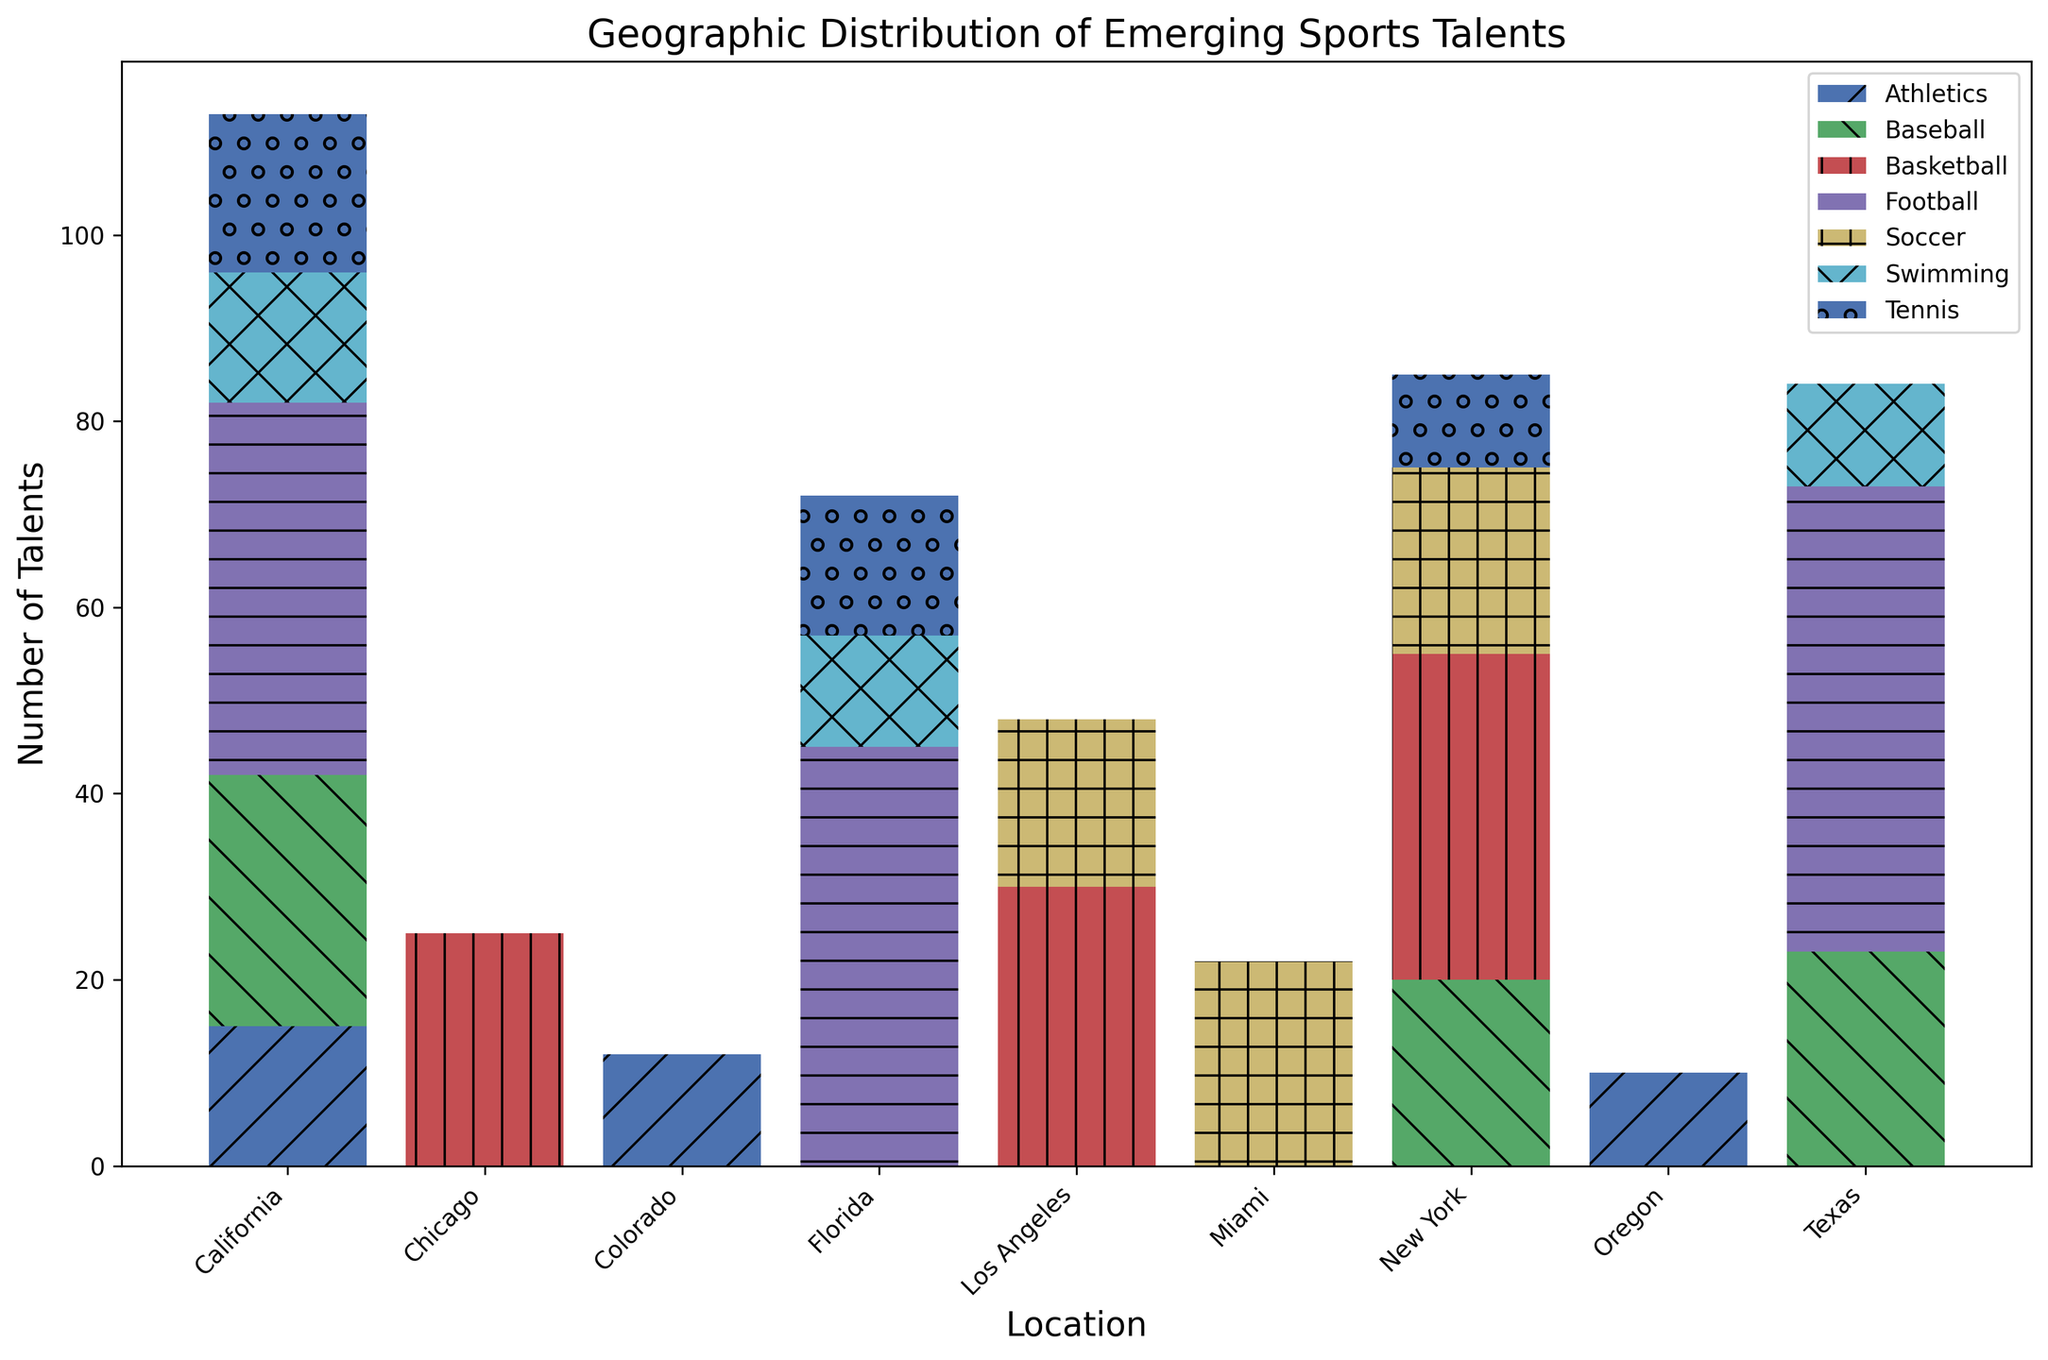What's the total number of talents identified in California? Sum the number of talents across all sports in California from the chart. Add together the counts for each sport: Basketball (40) + Football (40) + Baseball (27) + Tennis (17) + Swimming (14) + Athletics (15). Thus, the total is 40 + 40 + 27 + 17 + 14 + 15 = 153.
Answer: 153 Which location has the highest number of basketball talents? Compare the height of the basketball bars across all locations. New York has a basketball bar with a height representing 35 talents, which is the highest among all locations.
Answer: New York How many more football talents are identified in Texas than in Florida? Find the football talents in Texas (50) and Florida (45) from the chart. Compute the difference, 50 - 45 = 5.
Answer: 5 Which sport has the smallest number of emerging talents in New York? Compare the heights of all sports bars in New York. The smallest height bar corresponds to Tennis with 10 talents.
Answer: Tennis What is the average number of soccer talents across all the listed locations? Sum the number of soccer talents from New York (20), Los Angeles (18), and Miami (22). Compute the average: (20 + 18 + 22) / 3 = 60 / 3 = 20.
Answer: 20 Which city shows a higher overall number of talents in swimming, California or Texas? Compare the height of the swimming bars for California and Texas. California has 14 swimming talents, and Texas has 11. Therefore, California has a higher overall number of swimming talents.
Answer: California Is the total number of basketball talents higher than the total number of baseball talents across all locations? Sum the basketball talents across all locations: New York (35), Los Angeles (30), Chicago (25). Total is 35 + 30 + 25 = 90. Sum the baseball talents across all locations: California (27), Texas (23), New York (20). Total is 27 + 23 + 20 = 70. Compare: 90 is higher than 70.
Answer: Yes What is the total number of athletes in Oregon and Colorado combined? Find the number of athletes in Oregon (10) and Colorado (12). Add them together: 10 + 12 = 22.
Answer: 22 Which location has the most evenly distributed number of talents across different sports? Visually inspect the heights of the bars across different sports for each location to find the most similar heights. California appears to have a balanced distribution of talents in various sports (Basketball, Football, Baseball, Tennis, Swimming, Athletics).
Answer: California What’s the combined number of tennis and swimming talents in Florida? Add the number of tennis talents (15) and swimming talents (12) in Florida. 15 + 12 = 27.
Answer: 27 